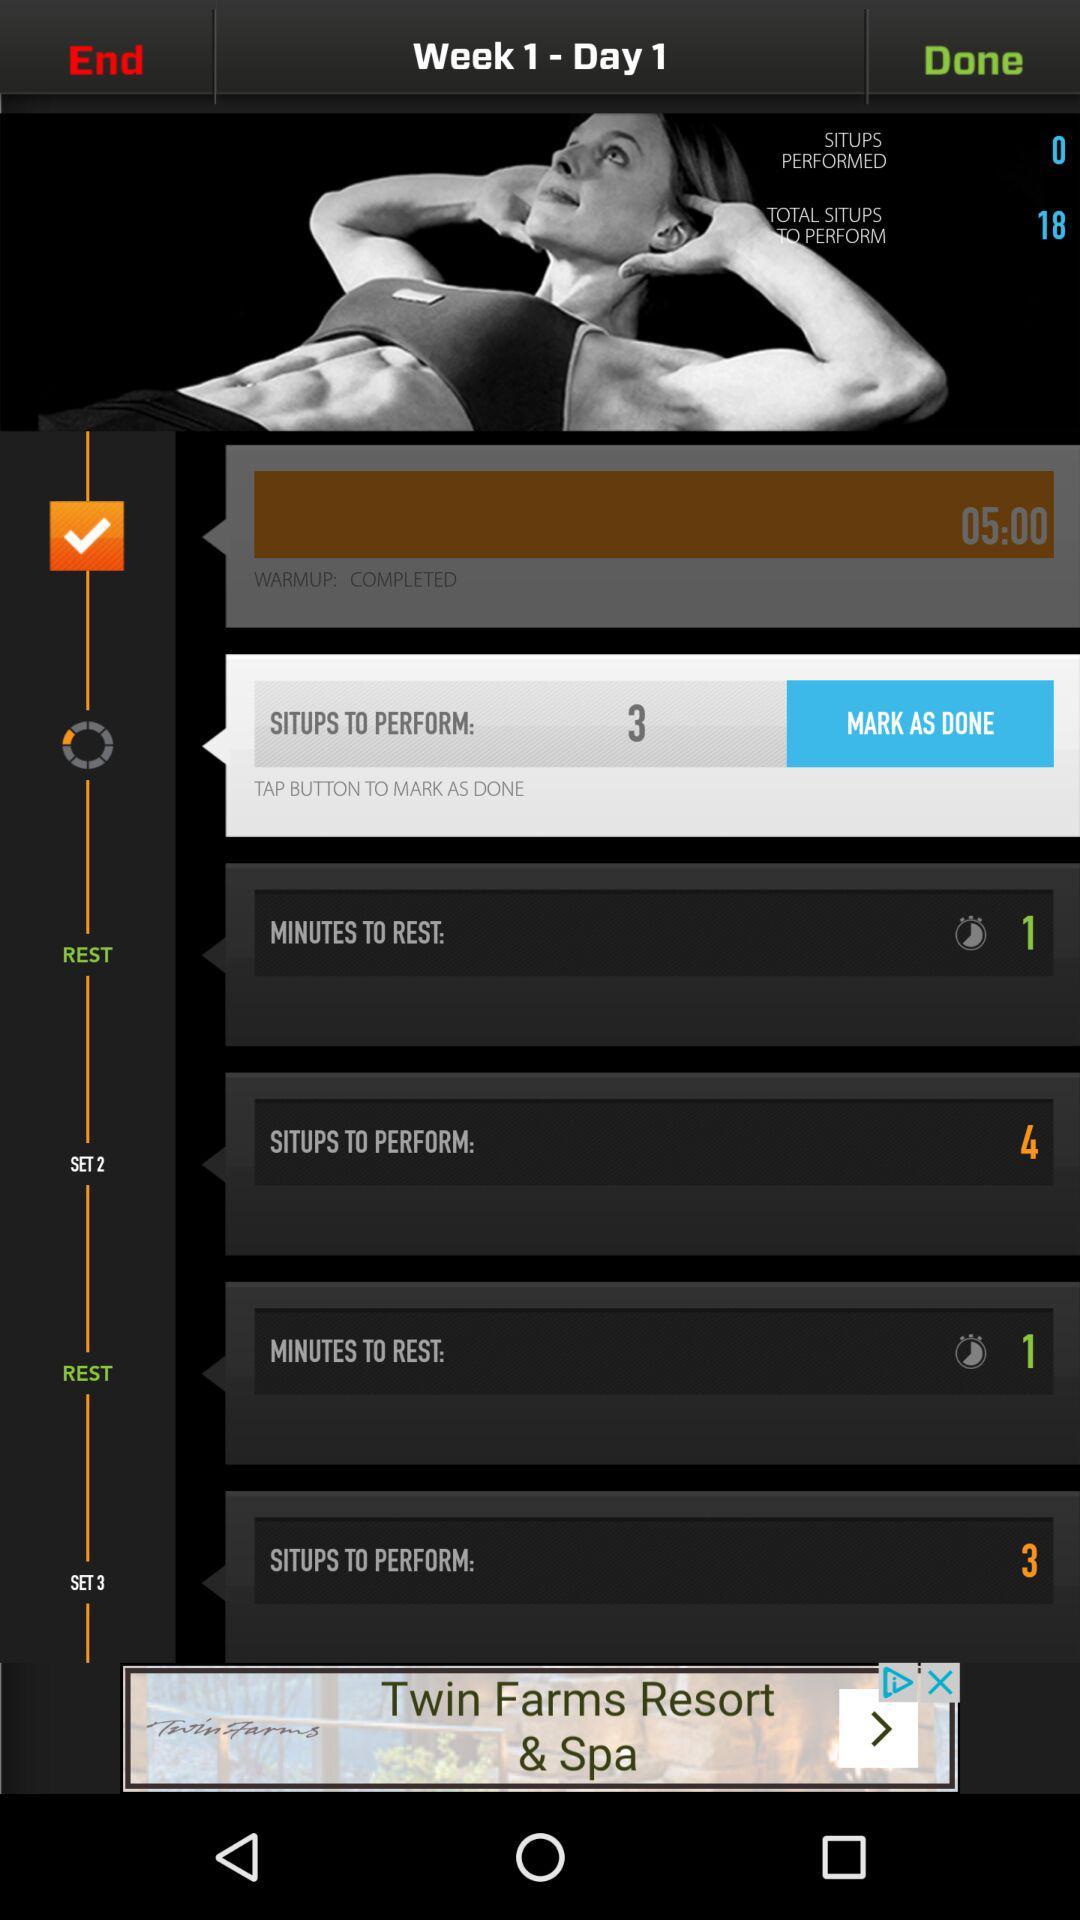Which week is going on? The week that is going on is 1. 